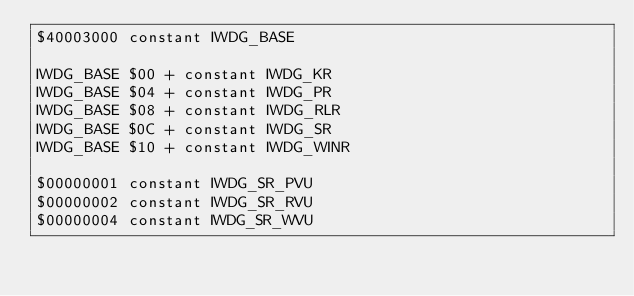Convert code to text. <code><loc_0><loc_0><loc_500><loc_500><_Forth_>$40003000 constant IWDG_BASE

IWDG_BASE $00 + constant IWDG_KR
IWDG_BASE $04 + constant IWDG_PR
IWDG_BASE $08 + constant IWDG_RLR
IWDG_BASE $0C + constant IWDG_SR
IWDG_BASE $10 + constant IWDG_WINR

$00000001 constant IWDG_SR_PVU
$00000002 constant IWDG_SR_RVU
$00000004 constant IWDG_SR_WVU
</code> 